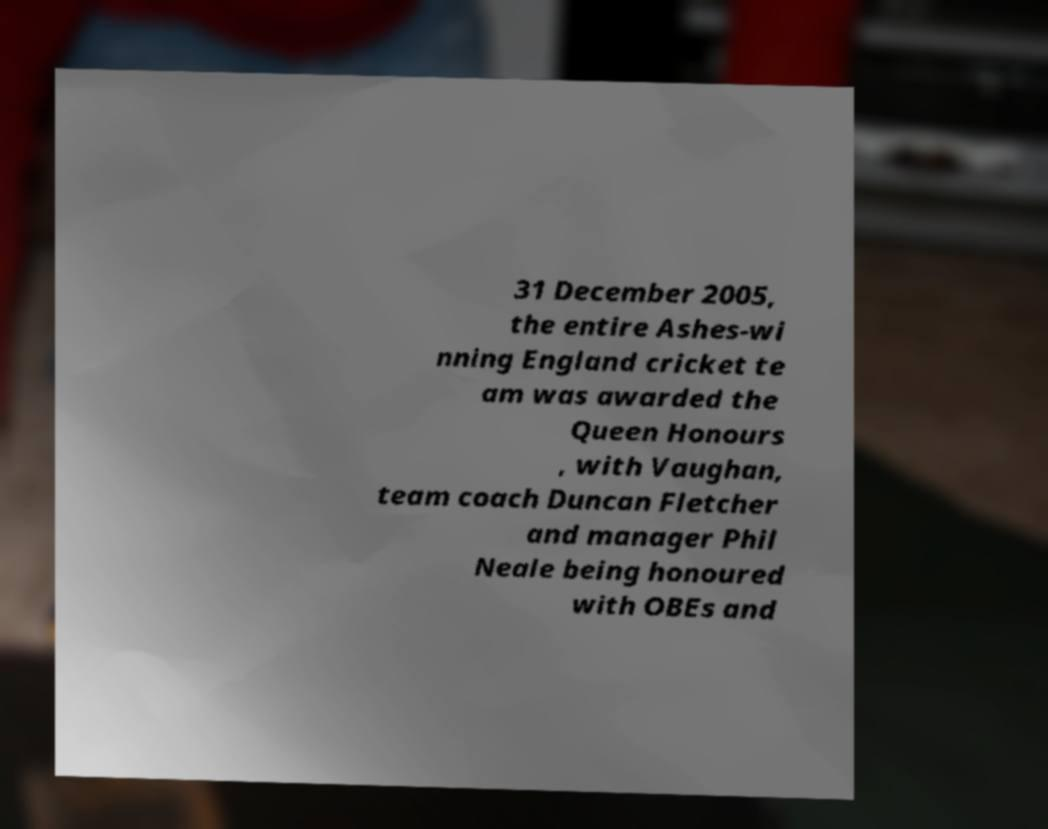Please read and relay the text visible in this image. What does it say? 31 December 2005, the entire Ashes-wi nning England cricket te am was awarded the Queen Honours , with Vaughan, team coach Duncan Fletcher and manager Phil Neale being honoured with OBEs and 